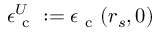<formula> <loc_0><loc_0><loc_500><loc_500>\epsilon _ { c } ^ { U } \colon = \epsilon _ { c } ( r _ { s } , 0 )</formula> 